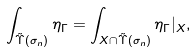Convert formula to latex. <formula><loc_0><loc_0><loc_500><loc_500>\int _ { \tilde { \Upsilon } ( \sigma _ { n } ) } \eta _ { \Gamma } = \int _ { X \cap \tilde { \Upsilon } ( \sigma _ { n } ) } \eta _ { \Gamma } | _ { X } ,</formula> 